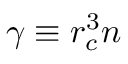<formula> <loc_0><loc_0><loc_500><loc_500>\gamma \equiv r _ { c } ^ { 3 } n</formula> 